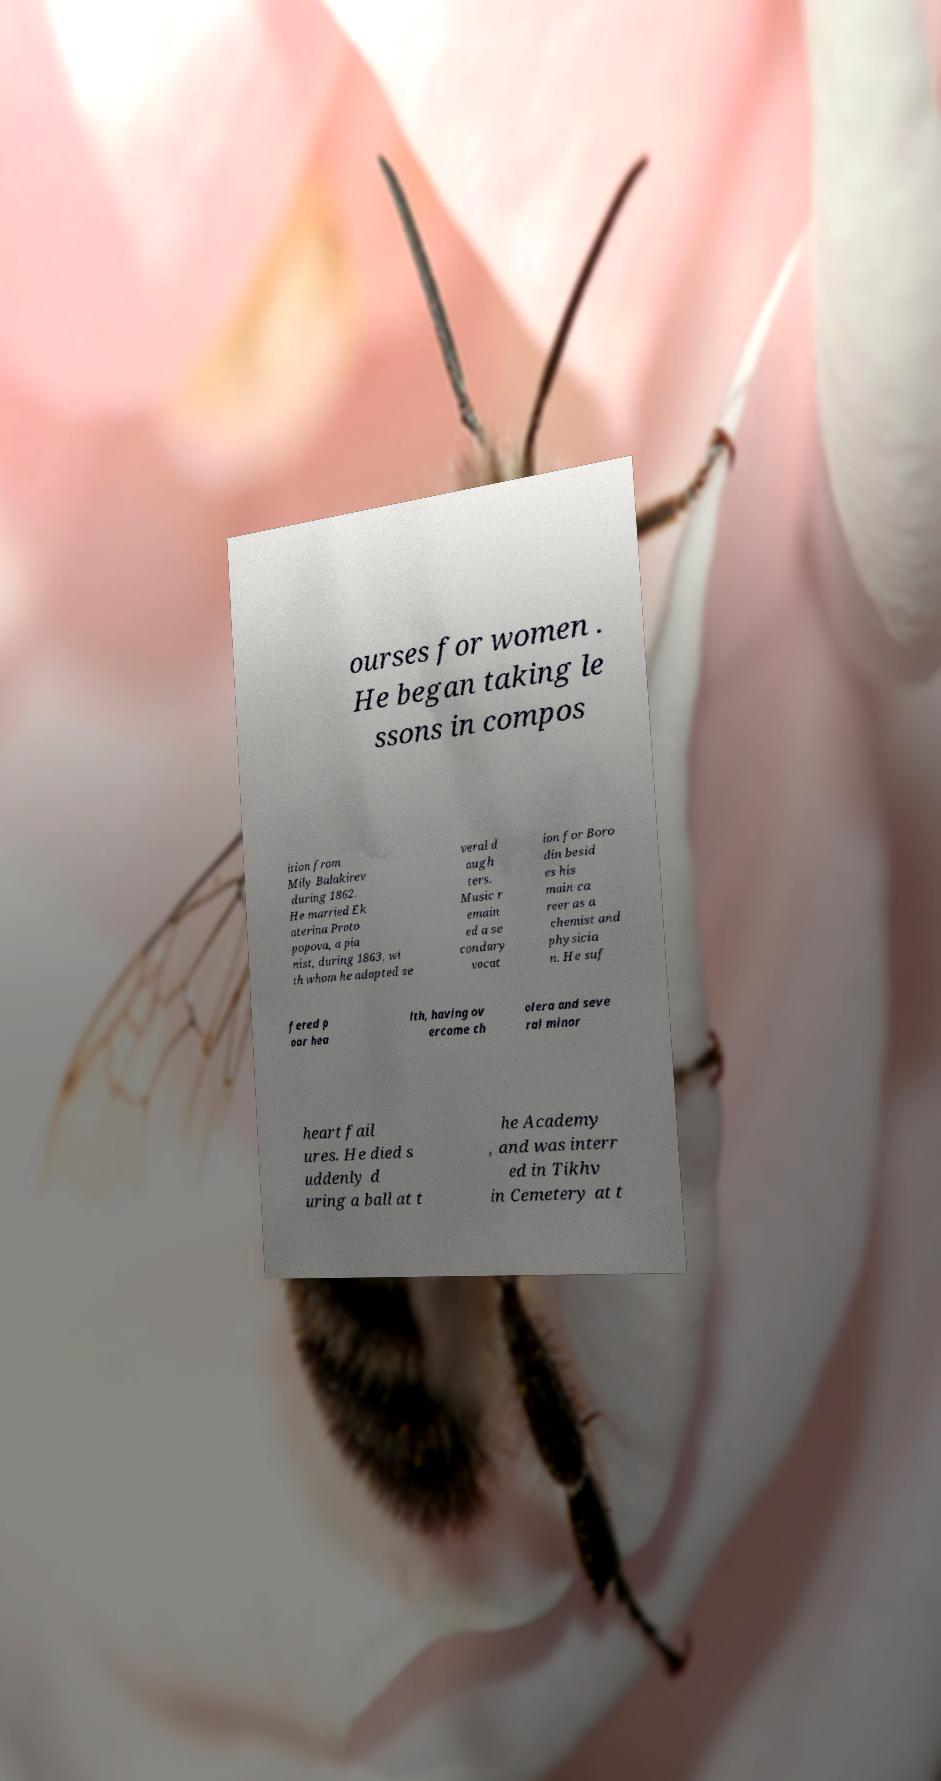For documentation purposes, I need the text within this image transcribed. Could you provide that? ourses for women . He began taking le ssons in compos ition from Mily Balakirev during 1862. He married Ek aterina Proto popova, a pia nist, during 1863, wi th whom he adopted se veral d augh ters. Music r emain ed a se condary vocat ion for Boro din besid es his main ca reer as a chemist and physicia n. He suf fered p oor hea lth, having ov ercome ch olera and seve ral minor heart fail ures. He died s uddenly d uring a ball at t he Academy , and was interr ed in Tikhv in Cemetery at t 